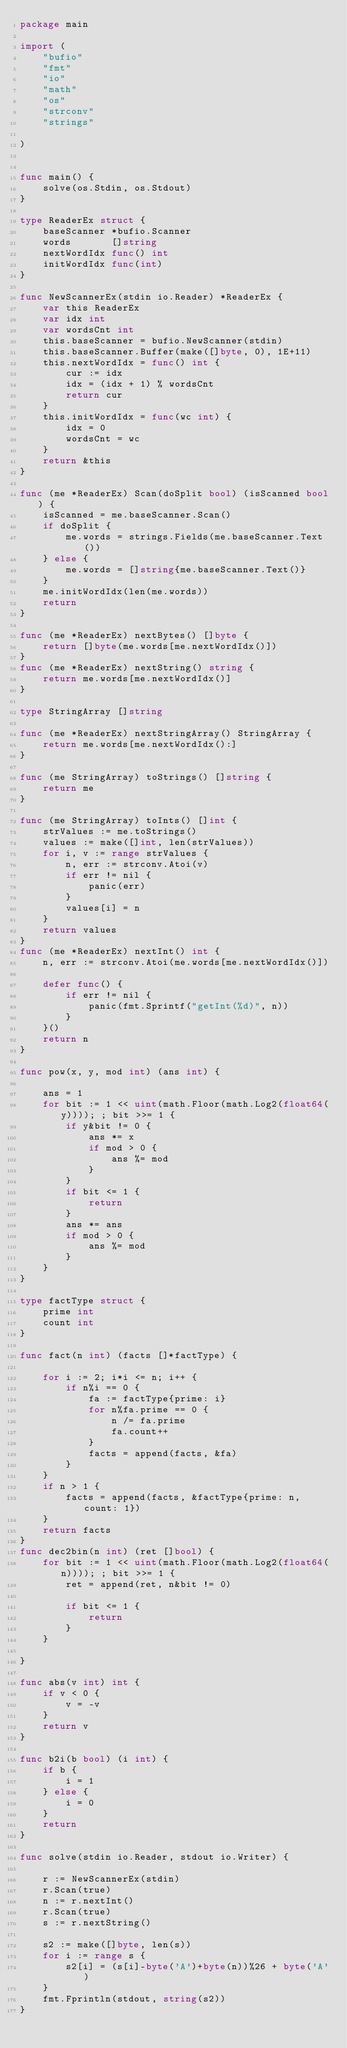Convert code to text. <code><loc_0><loc_0><loc_500><loc_500><_Go_>package main

import (
	"bufio"
	"fmt"
	"io"
	"math"
	"os"
	"strconv"
	"strings"

)


func main() {
	solve(os.Stdin, os.Stdout)
}

type ReaderEx struct {
	baseScanner *bufio.Scanner
	words       []string
	nextWordIdx func() int
	initWordIdx func(int)
}

func NewScannerEx(stdin io.Reader) *ReaderEx {
	var this ReaderEx
	var idx int
	var wordsCnt int
	this.baseScanner = bufio.NewScanner(stdin)
	this.baseScanner.Buffer(make([]byte, 0), 1E+11)
	this.nextWordIdx = func() int {
		cur := idx
		idx = (idx + 1) % wordsCnt
		return cur
	}
	this.initWordIdx = func(wc int) {
		idx = 0
		wordsCnt = wc
	}
	return &this
}

func (me *ReaderEx) Scan(doSplit bool) (isScanned bool) {
	isScanned = me.baseScanner.Scan()
	if doSplit {
		me.words = strings.Fields(me.baseScanner.Text())
	} else {
		me.words = []string{me.baseScanner.Text()}
	}
	me.initWordIdx(len(me.words))
	return
}

func (me *ReaderEx) nextBytes() []byte {
	return []byte(me.words[me.nextWordIdx()])
}
func (me *ReaderEx) nextString() string {
	return me.words[me.nextWordIdx()]
}

type StringArray []string

func (me *ReaderEx) nextStringArray() StringArray {
	return me.words[me.nextWordIdx():]
}

func (me StringArray) toStrings() []string {
	return me
}

func (me StringArray) toInts() []int {
	strValues := me.toStrings()
	values := make([]int, len(strValues))
	for i, v := range strValues {
		n, err := strconv.Atoi(v)
		if err != nil {
			panic(err)
		}
		values[i] = n
	}
	return values
}
func (me *ReaderEx) nextInt() int {
	n, err := strconv.Atoi(me.words[me.nextWordIdx()])

	defer func() {
		if err != nil {
			panic(fmt.Sprintf("getInt(%d)", n))
		}
	}()
	return n
}

func pow(x, y, mod int) (ans int) {

	ans = 1
	for bit := 1 << uint(math.Floor(math.Log2(float64(y)))); ; bit >>= 1 {
		if y&bit != 0 {
			ans *= x
			if mod > 0 {
				ans %= mod
			}
		}
		if bit <= 1 {
			return
		}
		ans *= ans
		if mod > 0 {
			ans %= mod
		}
	}
}

type factType struct {
	prime int
	count int
}

func fact(n int) (facts []*factType) {

	for i := 2; i*i <= n; i++ {
		if n%i == 0 {
			fa := factType{prime: i}
			for n%fa.prime == 0 {
				n /= fa.prime
				fa.count++
			}
			facts = append(facts, &fa)
		}
	}
	if n > 1 {
		facts = append(facts, &factType{prime: n, count: 1})
	}
	return facts
}
func dec2bin(n int) (ret []bool) {
	for bit := 1 << uint(math.Floor(math.Log2(float64(n)))); ; bit >>= 1 {
		ret = append(ret, n&bit != 0)

		if bit <= 1 {
			return
		}
	}

}

func abs(v int) int {
	if v < 0 {
		v = -v
	}
	return v
}

func b2i(b bool) (i int) {
	if b {
		i = 1
	} else {
		i = 0
	}
	return
}

func solve(stdin io.Reader, stdout io.Writer) {

	r := NewScannerEx(stdin)
	r.Scan(true)
	n := r.nextInt()
	r.Scan(true)
	s := r.nextString()

	s2 := make([]byte, len(s))
	for i := range s {
		s2[i] = (s[i]-byte('A')+byte(n))%26 + byte('A')
	}
	fmt.Fprintln(stdout, string(s2))
}
</code> 